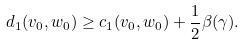Convert formula to latex. <formula><loc_0><loc_0><loc_500><loc_500>d _ { 1 } ( v _ { 0 } , w _ { 0 } ) \geq c _ { 1 } ( v _ { 0 } , w _ { 0 } ) + \frac { 1 } { 2 } \beta ( \gamma ) .</formula> 